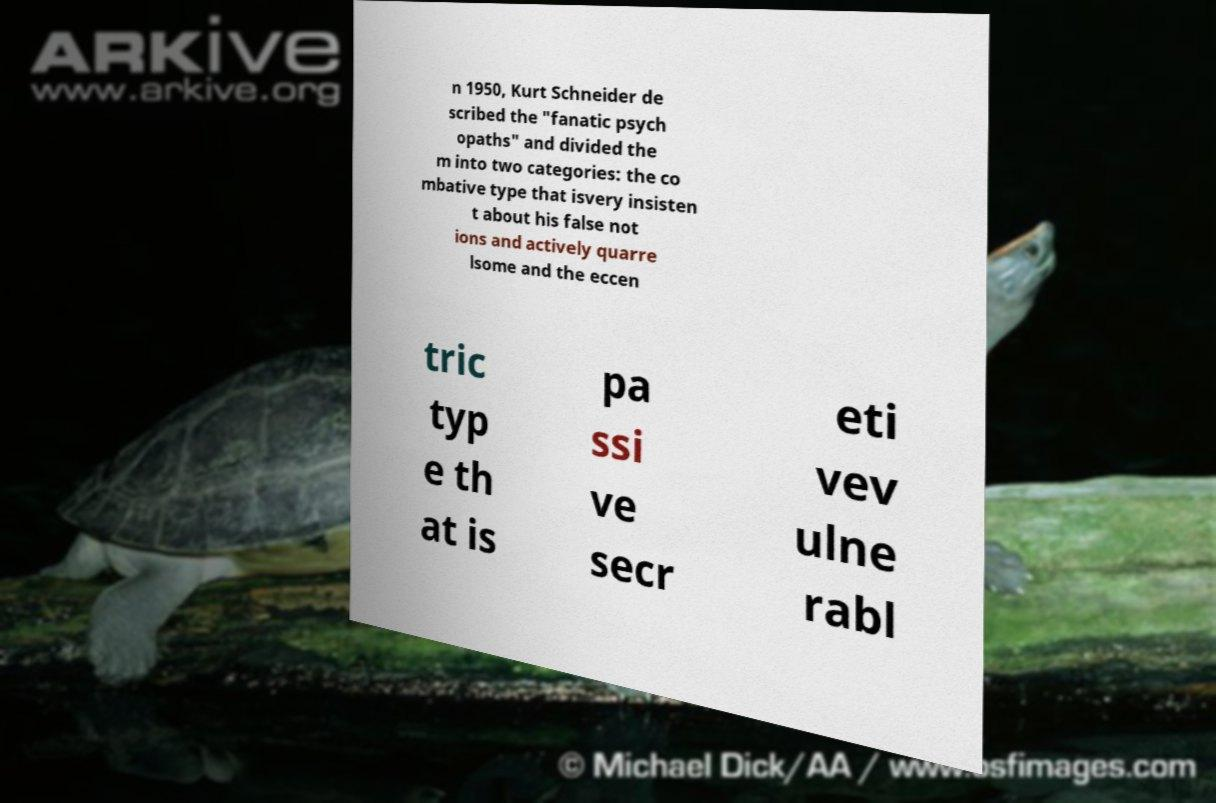There's text embedded in this image that I need extracted. Can you transcribe it verbatim? n 1950, Kurt Schneider de scribed the "fanatic psych opaths" and divided the m into two categories: the co mbative type that isvery insisten t about his false not ions and actively quarre lsome and the eccen tric typ e th at is pa ssi ve secr eti vev ulne rabl 